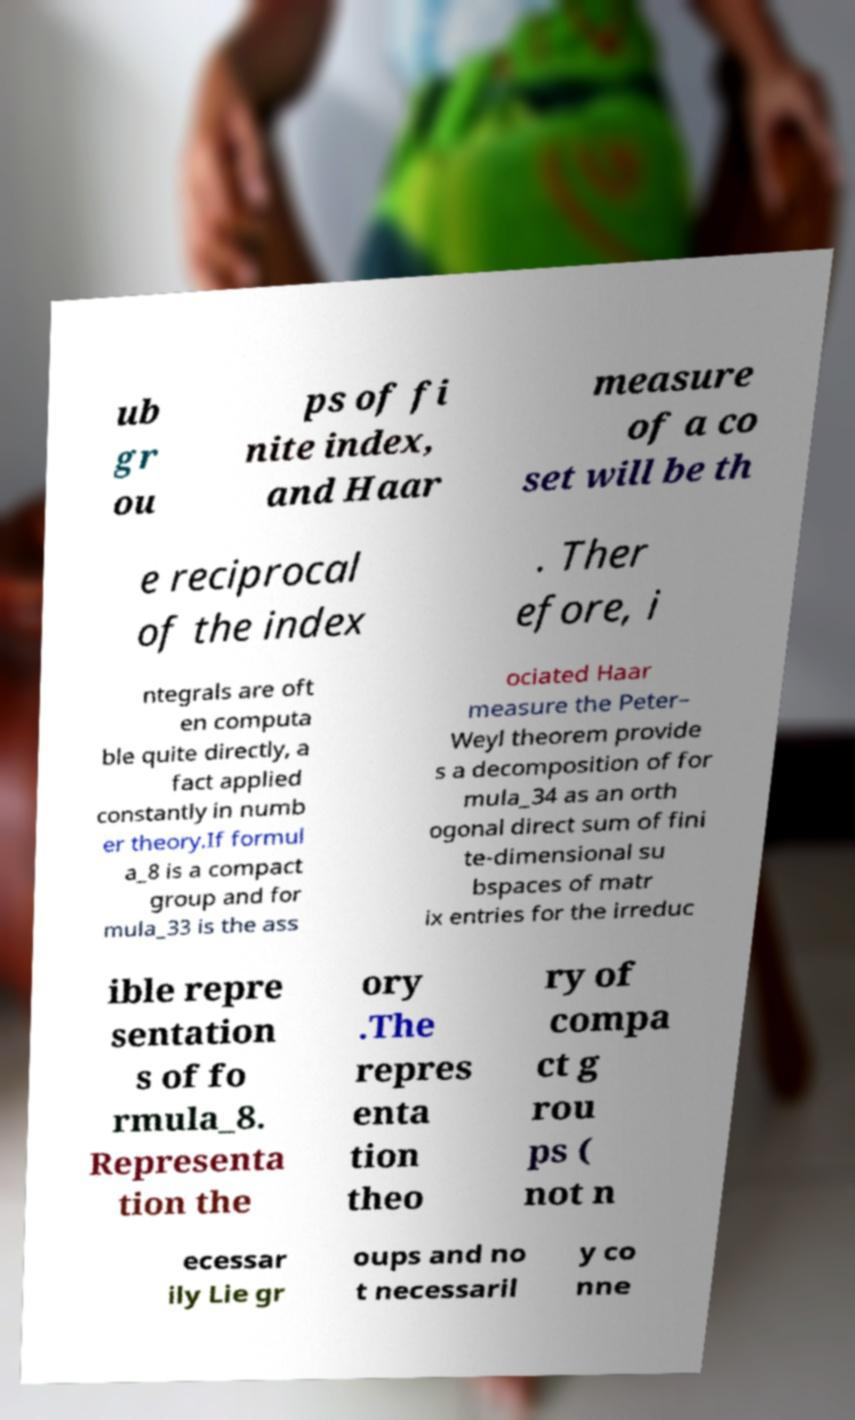Please read and relay the text visible in this image. What does it say? ub gr ou ps of fi nite index, and Haar measure of a co set will be th e reciprocal of the index . Ther efore, i ntegrals are oft en computa ble quite directly, a fact applied constantly in numb er theory.If formul a_8 is a compact group and for mula_33 is the ass ociated Haar measure the Peter– Weyl theorem provide s a decomposition of for mula_34 as an orth ogonal direct sum of fini te-dimensional su bspaces of matr ix entries for the irreduc ible repre sentation s of fo rmula_8. Representa tion the ory .The repres enta tion theo ry of compa ct g rou ps ( not n ecessar ily Lie gr oups and no t necessaril y co nne 